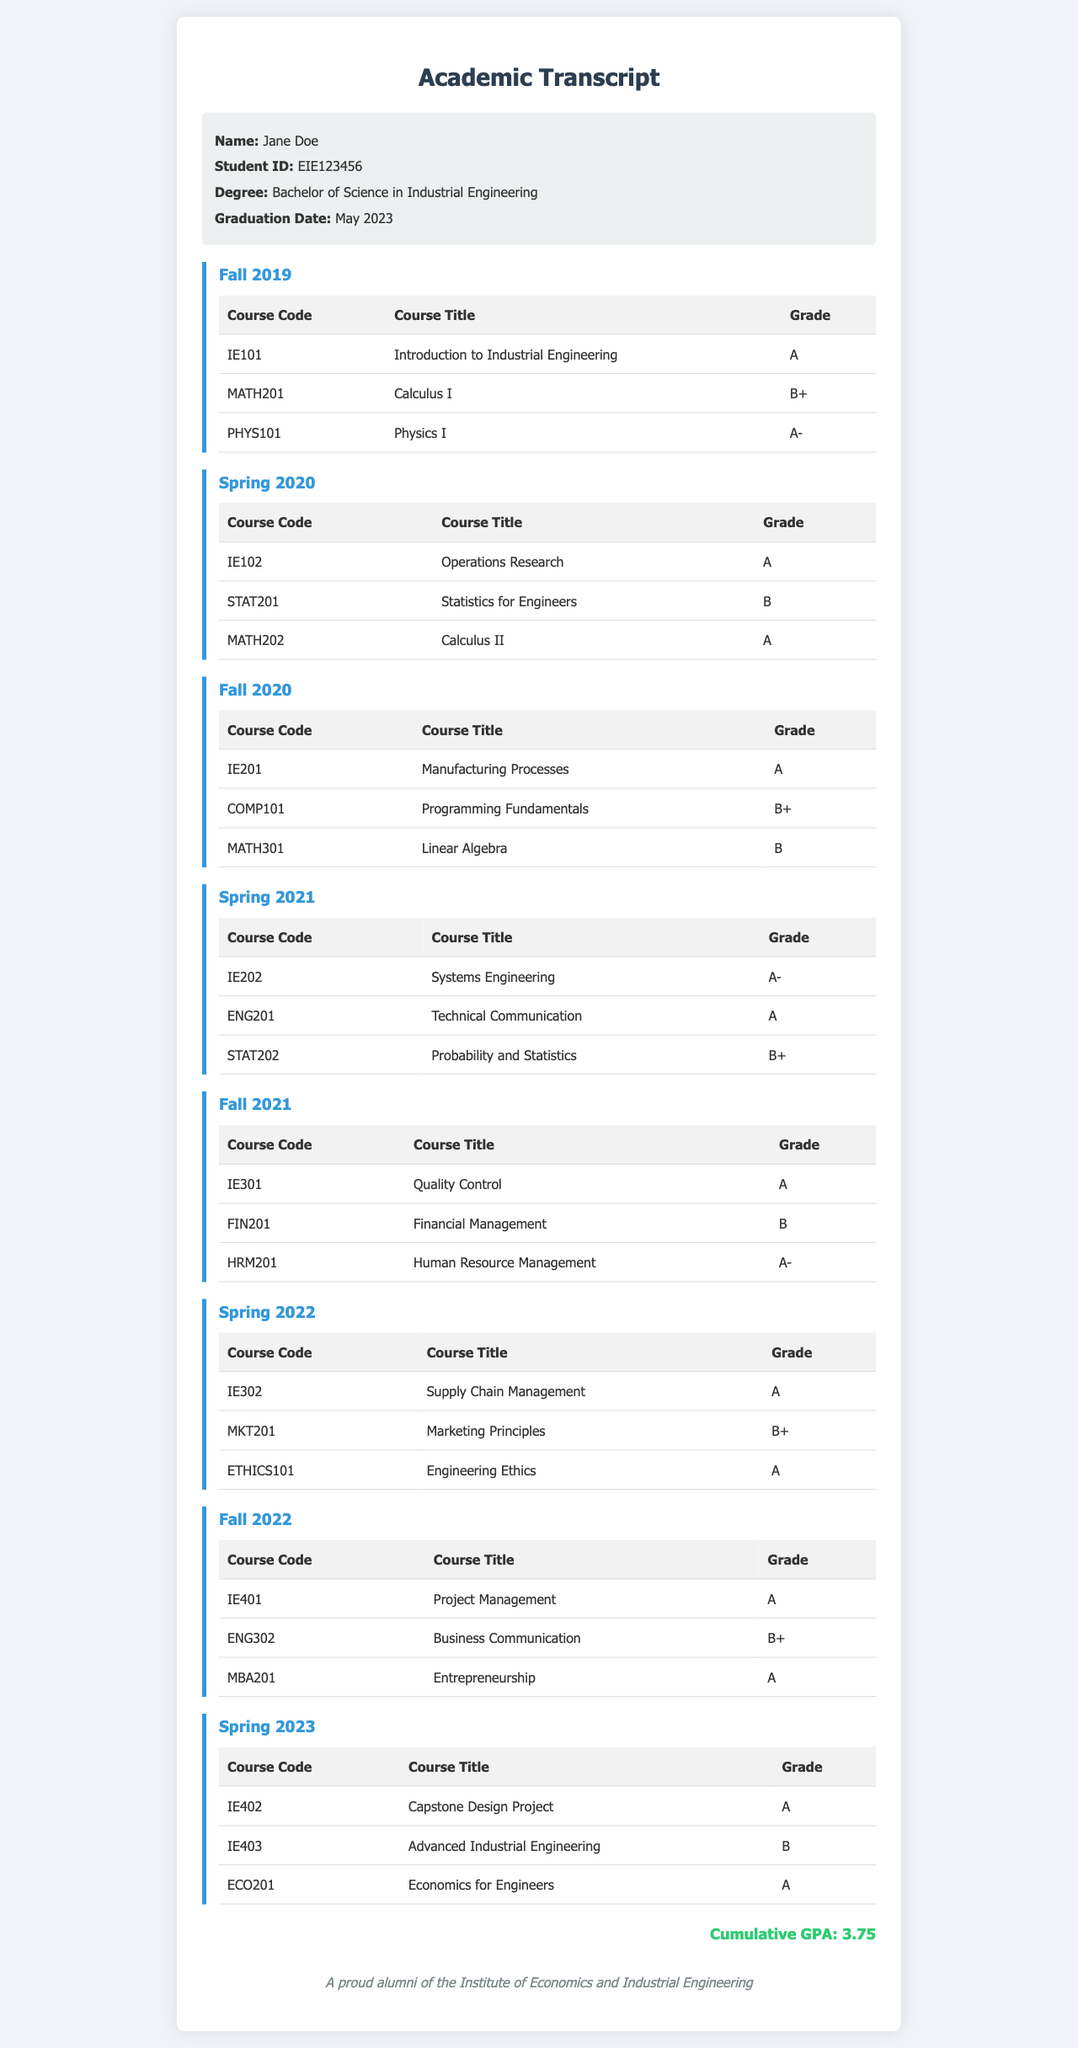What is the name of the student? The document provides personal information, and the student's name is listed at the top.
Answer: Jane Doe What is the graduation date? The graduation date is specified in the personal information section of the document.
Answer: May 2023 Which course received an A- grade in Spring 2021? This requires looking through the Spring 2021 semester table to find the grade of A-.
Answer: IE202 What is the cumulative GPA? The cumulative GPA is mentioned at the bottom of the document as a summary of the student's performance.
Answer: 3.75 What course was taken in Fall 2020 with the code COMP101? This requires identifying the course title corresponding to the code in the Fall 2020 semester table.
Answer: Programming Fundamentals Which semester includes the course "Supply Chain Management"? This question asks for the semester that features this specific course, requiring a search through the semester sections.
Answer: Spring 2022 How many courses were taken in Spring 2023? The Spring 2023 semester lists the number of courses taken, prompting a count of them.
Answer: 3 Which course in Fall 2021 received a grade of B? This will require checking the grades for each course in the Fall 2021 table to find B.
Answer: FIN201 What degree was earned by the student? The degree obtained by the student is indicated in the personal information section of the document.
Answer: Bachelor of Science in Industrial Engineering 